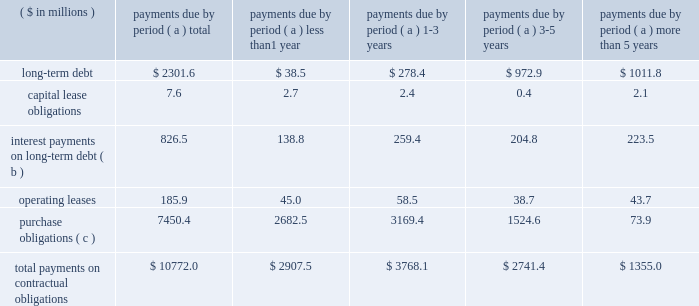Page 31 of 98 additional details about the company 2019s receivables sales agreement and debt are available in notes 6 and 12 , respectively , accompanying the consolidated financial statements within item 8 of this report .
Other liquidity items cash payments required for long-term debt maturities , rental payments under noncancellable operating leases and purchase obligations in effect at december 31 , 2006 , are summarized in the table: .
Total payments on contractual obligations $ 10772.0 $ 2907.5 $ 3768.1 $ 2741.4 $ 1355.0 ( a ) amounts reported in local currencies have been translated at the year-end exchange rates .
( b ) for variable rate facilities , amounts are based on interest rates in effect at year end .
( c ) the company 2019s purchase obligations include contracted amounts for aluminum , steel , plastic resin and other direct materials .
Also included are commitments for purchases of natural gas and electricity , aerospace and technologies contracts and other less significant items .
In cases where variable prices and/or usage are involved , management 2019s best estimates have been used .
Depending on the circumstances , early termination of the contracts may not result in penalties and , therefore , actual payments could vary significantly .
Contributions to the company 2019s defined benefit pension plans , not including the unfunded german plans , are expected to be $ 69.1 million in 2007 .
This estimate may change based on plan asset performance .
Benefit payments related to these plans are expected to be $ 62.6 million , $ 65.1 million , $ 68.9 million , $ 73.9 million and $ 75.1 million for the years ending december 31 , 2007 through 2011 , respectively , and $ 436.7 million combined for 2012 through 2016 .
Payments to participants in the unfunded german plans are expected to be $ 24.6 million , $ 25.1 million , $ 25.5 million , $ 25.9 million and $ 26.1 million in the years 2007 through 2011 , respectively , and a total of $ 136.6 million thereafter .
We reduced our share repurchase program in 2006 to $ 45.7 million , net of issuances , compared to $ 358.1 million net repurchases in 2005 and $ 50 million in 2004 .
The net repurchases in 2006 did not include a forward contract entered into in december 2006 for the repurchase of 1200000 shares .
The contract was settled on january 5 , 2007 , for $ 51.9 million in cash .
In 2007 we expect to repurchase approximately $ 175 million , net of issuances , and to reduce debt levels by more than $ 125 million .
Annual cash dividends paid on common stock were 40 cents per share in 2006 and 2005 and 35 cents per share in 2004 .
Total dividends paid were $ 41 million in 2006 , $ 42.5 million in 2005 and $ 38.9 million in 2004. .
How much cash would the company have retained had it not paid dividends in 2006 , 2005 , and 2004 ( in millions? )? 
Computations: ((41 + 42.5) + 38.9)
Answer: 122.4. Page 31 of 98 additional details about the company 2019s receivables sales agreement and debt are available in notes 6 and 12 , respectively , accompanying the consolidated financial statements within item 8 of this report .
Other liquidity items cash payments required for long-term debt maturities , rental payments under noncancellable operating leases and purchase obligations in effect at december 31 , 2006 , are summarized in the table: .
Total payments on contractual obligations $ 10772.0 $ 2907.5 $ 3768.1 $ 2741.4 $ 1355.0 ( a ) amounts reported in local currencies have been translated at the year-end exchange rates .
( b ) for variable rate facilities , amounts are based on interest rates in effect at year end .
( c ) the company 2019s purchase obligations include contracted amounts for aluminum , steel , plastic resin and other direct materials .
Also included are commitments for purchases of natural gas and electricity , aerospace and technologies contracts and other less significant items .
In cases where variable prices and/or usage are involved , management 2019s best estimates have been used .
Depending on the circumstances , early termination of the contracts may not result in penalties and , therefore , actual payments could vary significantly .
Contributions to the company 2019s defined benefit pension plans , not including the unfunded german plans , are expected to be $ 69.1 million in 2007 .
This estimate may change based on plan asset performance .
Benefit payments related to these plans are expected to be $ 62.6 million , $ 65.1 million , $ 68.9 million , $ 73.9 million and $ 75.1 million for the years ending december 31 , 2007 through 2011 , respectively , and $ 436.7 million combined for 2012 through 2016 .
Payments to participants in the unfunded german plans are expected to be $ 24.6 million , $ 25.1 million , $ 25.5 million , $ 25.9 million and $ 26.1 million in the years 2007 through 2011 , respectively , and a total of $ 136.6 million thereafter .
We reduced our share repurchase program in 2006 to $ 45.7 million , net of issuances , compared to $ 358.1 million net repurchases in 2005 and $ 50 million in 2004 .
The net repurchases in 2006 did not include a forward contract entered into in december 2006 for the repurchase of 1200000 shares .
The contract was settled on january 5 , 2007 , for $ 51.9 million in cash .
In 2007 we expect to repurchase approximately $ 175 million , net of issuances , and to reduce debt levels by more than $ 125 million .
Annual cash dividends paid on common stock were 40 cents per share in 2006 and 2005 and 35 cents per share in 2004 .
Total dividends paid were $ 41 million in 2006 , $ 42.5 million in 2005 and $ 38.9 million in 2004. .
What percentage of total payments on contractual obligations are due to long-term debt at december 301 , 2006? 
Computations: (2301.6 / 10772.0)
Answer: 0.21367. Page 31 of 98 additional details about the company 2019s receivables sales agreement and debt are available in notes 6 and 12 , respectively , accompanying the consolidated financial statements within item 8 of this report .
Other liquidity items cash payments required for long-term debt maturities , rental payments under noncancellable operating leases and purchase obligations in effect at december 31 , 2006 , are summarized in the table: .
Total payments on contractual obligations $ 10772.0 $ 2907.5 $ 3768.1 $ 2741.4 $ 1355.0 ( a ) amounts reported in local currencies have been translated at the year-end exchange rates .
( b ) for variable rate facilities , amounts are based on interest rates in effect at year end .
( c ) the company 2019s purchase obligations include contracted amounts for aluminum , steel , plastic resin and other direct materials .
Also included are commitments for purchases of natural gas and electricity , aerospace and technologies contracts and other less significant items .
In cases where variable prices and/or usage are involved , management 2019s best estimates have been used .
Depending on the circumstances , early termination of the contracts may not result in penalties and , therefore , actual payments could vary significantly .
Contributions to the company 2019s defined benefit pension plans , not including the unfunded german plans , are expected to be $ 69.1 million in 2007 .
This estimate may change based on plan asset performance .
Benefit payments related to these plans are expected to be $ 62.6 million , $ 65.1 million , $ 68.9 million , $ 73.9 million and $ 75.1 million for the years ending december 31 , 2007 through 2011 , respectively , and $ 436.7 million combined for 2012 through 2016 .
Payments to participants in the unfunded german plans are expected to be $ 24.6 million , $ 25.1 million , $ 25.5 million , $ 25.9 million and $ 26.1 million in the years 2007 through 2011 , respectively , and a total of $ 136.6 million thereafter .
We reduced our share repurchase program in 2006 to $ 45.7 million , net of issuances , compared to $ 358.1 million net repurchases in 2005 and $ 50 million in 2004 .
The net repurchases in 2006 did not include a forward contract entered into in december 2006 for the repurchase of 1200000 shares .
The contract was settled on january 5 , 2007 , for $ 51.9 million in cash .
In 2007 we expect to repurchase approximately $ 175 million , net of issuances , and to reduce debt levels by more than $ 125 million .
Annual cash dividends paid on common stock were 40 cents per share in 2006 and 2005 and 35 cents per share in 2004 .
Total dividends paid were $ 41 million in 2006 , $ 42.5 million in 2005 and $ 38.9 million in 2004. .
What percentage of total payments on contractual obligations are due to interest payments on long-term debt at december 301 , 2006? 
Computations: (826.5 / 10772.0)
Answer: 0.07673. 